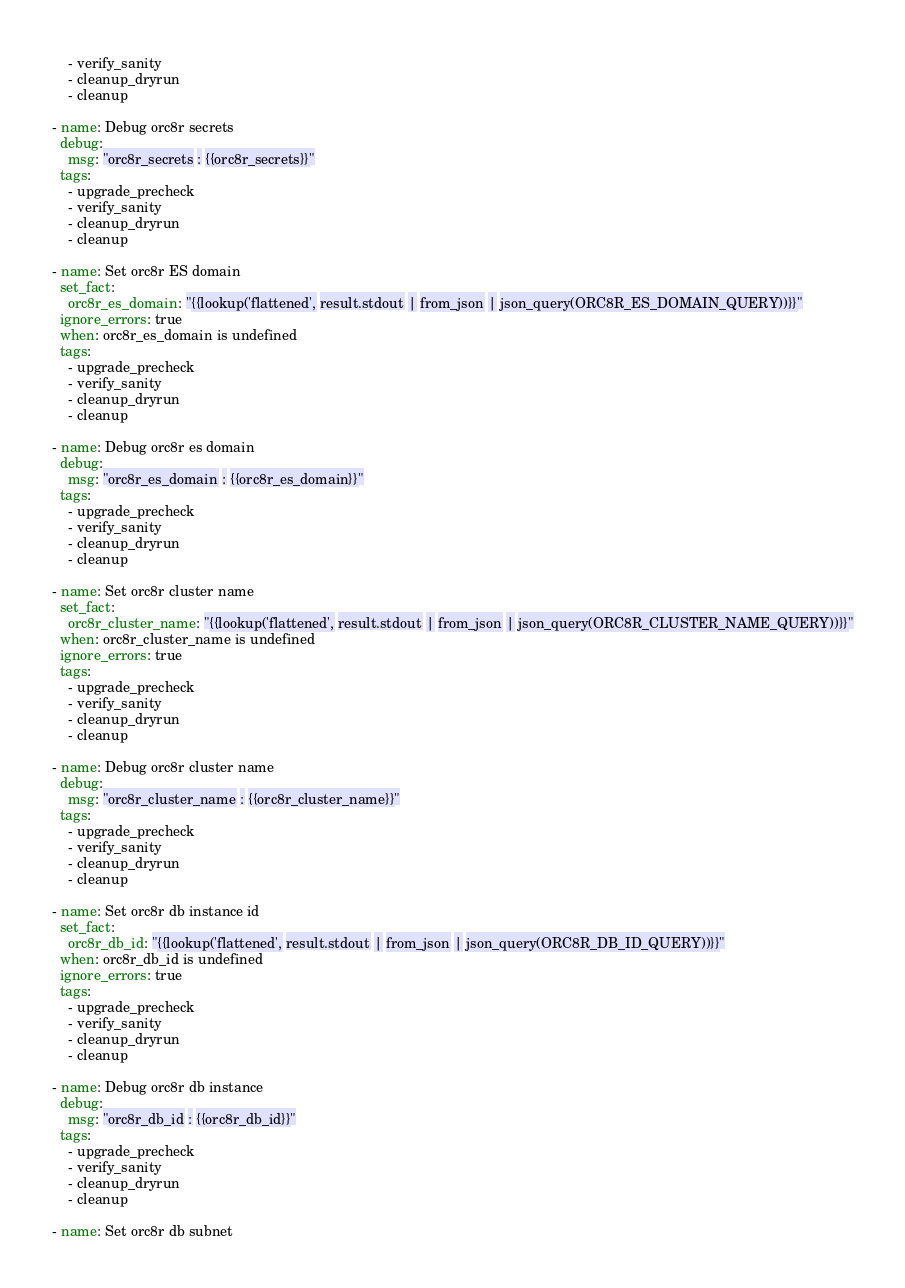Convert code to text. <code><loc_0><loc_0><loc_500><loc_500><_YAML_>    - verify_sanity
    - cleanup_dryrun
    - cleanup

- name: Debug orc8r secrets
  debug:
    msg: "orc8r_secrets : {{orc8r_secrets}}"
  tags:
    - upgrade_precheck
    - verify_sanity
    - cleanup_dryrun
    - cleanup

- name: Set orc8r ES domain
  set_fact:
    orc8r_es_domain: "{{lookup('flattened', result.stdout | from_json | json_query(ORC8R_ES_DOMAIN_QUERY))}}"
  ignore_errors: true
  when: orc8r_es_domain is undefined
  tags:
    - upgrade_precheck
    - verify_sanity
    - cleanup_dryrun
    - cleanup

- name: Debug orc8r es domain
  debug:
    msg: "orc8r_es_domain : {{orc8r_es_domain}}"
  tags:
    - upgrade_precheck
    - verify_sanity
    - cleanup_dryrun
    - cleanup

- name: Set orc8r cluster name
  set_fact:
    orc8r_cluster_name: "{{lookup('flattened', result.stdout | from_json | json_query(ORC8R_CLUSTER_NAME_QUERY))}}"
  when: orc8r_cluster_name is undefined
  ignore_errors: true
  tags:
    - upgrade_precheck
    - verify_sanity
    - cleanup_dryrun
    - cleanup

- name: Debug orc8r cluster name
  debug:
    msg: "orc8r_cluster_name : {{orc8r_cluster_name}}"
  tags:
    - upgrade_precheck
    - verify_sanity
    - cleanup_dryrun
    - cleanup

- name: Set orc8r db instance id
  set_fact:
    orc8r_db_id: "{{lookup('flattened', result.stdout | from_json | json_query(ORC8R_DB_ID_QUERY))}}"
  when: orc8r_db_id is undefined
  ignore_errors: true
  tags:
    - upgrade_precheck
    - verify_sanity
    - cleanup_dryrun
    - cleanup

- name: Debug orc8r db instance
  debug:
    msg: "orc8r_db_id : {{orc8r_db_id}}"
  tags:
    - upgrade_precheck
    - verify_sanity
    - cleanup_dryrun
    - cleanup

- name: Set orc8r db subnet</code> 